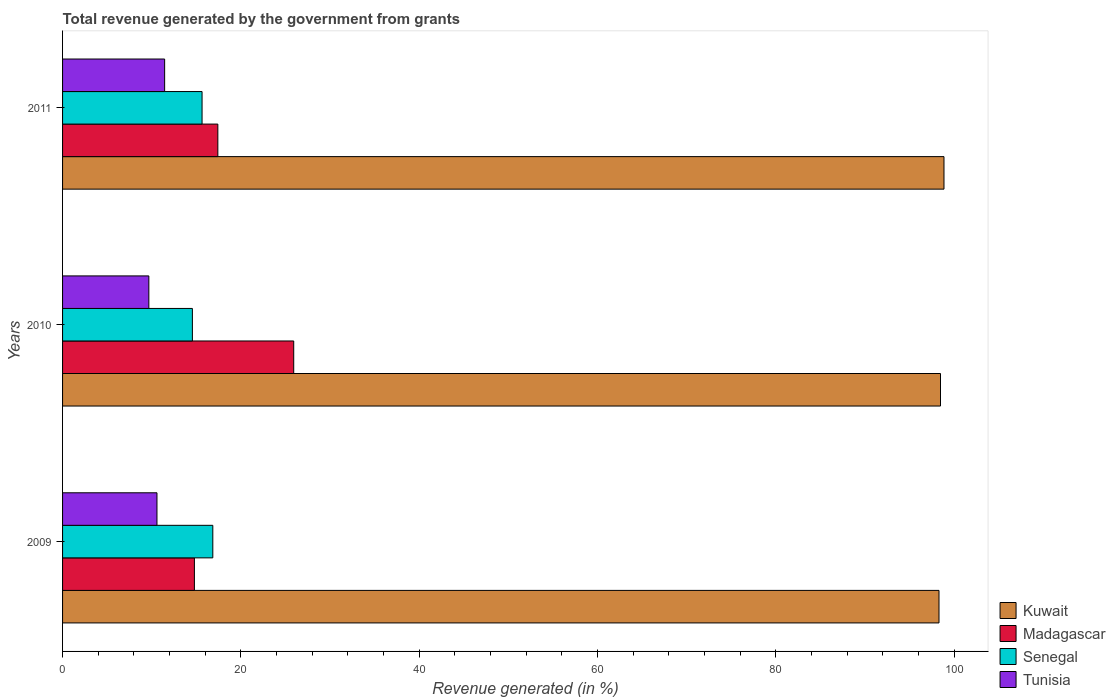Are the number of bars per tick equal to the number of legend labels?
Make the answer very short. Yes. What is the label of the 2nd group of bars from the top?
Provide a short and direct response. 2010. What is the total revenue generated in Madagascar in 2009?
Make the answer very short. 14.79. Across all years, what is the maximum total revenue generated in Senegal?
Offer a terse response. 16.85. Across all years, what is the minimum total revenue generated in Senegal?
Provide a short and direct response. 14.56. In which year was the total revenue generated in Tunisia minimum?
Your answer should be compact. 2010. What is the total total revenue generated in Madagascar in the graph?
Provide a short and direct response. 58.13. What is the difference between the total revenue generated in Senegal in 2009 and that in 2010?
Your answer should be very brief. 2.29. What is the difference between the total revenue generated in Senegal in 2010 and the total revenue generated in Tunisia in 2011?
Offer a very short reply. 3.11. What is the average total revenue generated in Senegal per year?
Your answer should be very brief. 15.69. In the year 2009, what is the difference between the total revenue generated in Madagascar and total revenue generated in Senegal?
Keep it short and to the point. -2.07. What is the ratio of the total revenue generated in Tunisia in 2009 to that in 2011?
Keep it short and to the point. 0.92. Is the total revenue generated in Senegal in 2009 less than that in 2011?
Ensure brevity in your answer.  No. What is the difference between the highest and the second highest total revenue generated in Tunisia?
Offer a terse response. 0.86. What is the difference between the highest and the lowest total revenue generated in Kuwait?
Your response must be concise. 0.56. In how many years, is the total revenue generated in Tunisia greater than the average total revenue generated in Tunisia taken over all years?
Your answer should be compact. 2. Is the sum of the total revenue generated in Tunisia in 2009 and 2010 greater than the maximum total revenue generated in Madagascar across all years?
Your answer should be very brief. No. Is it the case that in every year, the sum of the total revenue generated in Tunisia and total revenue generated in Kuwait is greater than the sum of total revenue generated in Madagascar and total revenue generated in Senegal?
Give a very brief answer. Yes. What does the 4th bar from the top in 2009 represents?
Offer a very short reply. Kuwait. What does the 3rd bar from the bottom in 2009 represents?
Your response must be concise. Senegal. Is it the case that in every year, the sum of the total revenue generated in Tunisia and total revenue generated in Kuwait is greater than the total revenue generated in Senegal?
Offer a very short reply. Yes. How many bars are there?
Give a very brief answer. 12. Where does the legend appear in the graph?
Your response must be concise. Bottom right. How many legend labels are there?
Offer a very short reply. 4. How are the legend labels stacked?
Your answer should be compact. Vertical. What is the title of the graph?
Your answer should be very brief. Total revenue generated by the government from grants. Does "Albania" appear as one of the legend labels in the graph?
Provide a succinct answer. No. What is the label or title of the X-axis?
Provide a short and direct response. Revenue generated (in %). What is the label or title of the Y-axis?
Provide a succinct answer. Years. What is the Revenue generated (in %) of Kuwait in 2009?
Offer a terse response. 98.31. What is the Revenue generated (in %) of Madagascar in 2009?
Provide a short and direct response. 14.79. What is the Revenue generated (in %) of Senegal in 2009?
Make the answer very short. 16.85. What is the Revenue generated (in %) of Tunisia in 2009?
Your response must be concise. 10.59. What is the Revenue generated (in %) of Kuwait in 2010?
Make the answer very short. 98.47. What is the Revenue generated (in %) in Madagascar in 2010?
Your response must be concise. 25.93. What is the Revenue generated (in %) in Senegal in 2010?
Ensure brevity in your answer.  14.56. What is the Revenue generated (in %) of Tunisia in 2010?
Keep it short and to the point. 9.68. What is the Revenue generated (in %) in Kuwait in 2011?
Provide a short and direct response. 98.86. What is the Revenue generated (in %) of Madagascar in 2011?
Give a very brief answer. 17.42. What is the Revenue generated (in %) in Senegal in 2011?
Ensure brevity in your answer.  15.65. What is the Revenue generated (in %) of Tunisia in 2011?
Your response must be concise. 11.45. Across all years, what is the maximum Revenue generated (in %) in Kuwait?
Your response must be concise. 98.86. Across all years, what is the maximum Revenue generated (in %) of Madagascar?
Offer a very short reply. 25.93. Across all years, what is the maximum Revenue generated (in %) in Senegal?
Make the answer very short. 16.85. Across all years, what is the maximum Revenue generated (in %) of Tunisia?
Your answer should be compact. 11.45. Across all years, what is the minimum Revenue generated (in %) of Kuwait?
Offer a terse response. 98.31. Across all years, what is the minimum Revenue generated (in %) in Madagascar?
Your response must be concise. 14.79. Across all years, what is the minimum Revenue generated (in %) of Senegal?
Offer a very short reply. 14.56. Across all years, what is the minimum Revenue generated (in %) of Tunisia?
Your answer should be compact. 9.68. What is the total Revenue generated (in %) of Kuwait in the graph?
Give a very brief answer. 295.64. What is the total Revenue generated (in %) in Madagascar in the graph?
Provide a short and direct response. 58.13. What is the total Revenue generated (in %) in Senegal in the graph?
Ensure brevity in your answer.  47.06. What is the total Revenue generated (in %) of Tunisia in the graph?
Provide a short and direct response. 31.71. What is the difference between the Revenue generated (in %) of Kuwait in 2009 and that in 2010?
Your answer should be compact. -0.17. What is the difference between the Revenue generated (in %) in Madagascar in 2009 and that in 2010?
Provide a short and direct response. -11.14. What is the difference between the Revenue generated (in %) in Senegal in 2009 and that in 2010?
Your answer should be compact. 2.29. What is the difference between the Revenue generated (in %) of Tunisia in 2009 and that in 2010?
Provide a succinct answer. 0.91. What is the difference between the Revenue generated (in %) in Kuwait in 2009 and that in 2011?
Make the answer very short. -0.56. What is the difference between the Revenue generated (in %) in Madagascar in 2009 and that in 2011?
Provide a short and direct response. -2.63. What is the difference between the Revenue generated (in %) of Senegal in 2009 and that in 2011?
Offer a very short reply. 1.21. What is the difference between the Revenue generated (in %) in Tunisia in 2009 and that in 2011?
Offer a terse response. -0.86. What is the difference between the Revenue generated (in %) of Kuwait in 2010 and that in 2011?
Your answer should be very brief. -0.39. What is the difference between the Revenue generated (in %) in Madagascar in 2010 and that in 2011?
Your response must be concise. 8.51. What is the difference between the Revenue generated (in %) of Senegal in 2010 and that in 2011?
Provide a succinct answer. -1.08. What is the difference between the Revenue generated (in %) in Tunisia in 2010 and that in 2011?
Make the answer very short. -1.77. What is the difference between the Revenue generated (in %) in Kuwait in 2009 and the Revenue generated (in %) in Madagascar in 2010?
Provide a succinct answer. 72.38. What is the difference between the Revenue generated (in %) in Kuwait in 2009 and the Revenue generated (in %) in Senegal in 2010?
Keep it short and to the point. 83.74. What is the difference between the Revenue generated (in %) of Kuwait in 2009 and the Revenue generated (in %) of Tunisia in 2010?
Ensure brevity in your answer.  88.63. What is the difference between the Revenue generated (in %) in Madagascar in 2009 and the Revenue generated (in %) in Senegal in 2010?
Make the answer very short. 0.23. What is the difference between the Revenue generated (in %) in Madagascar in 2009 and the Revenue generated (in %) in Tunisia in 2010?
Give a very brief answer. 5.11. What is the difference between the Revenue generated (in %) in Senegal in 2009 and the Revenue generated (in %) in Tunisia in 2010?
Provide a short and direct response. 7.18. What is the difference between the Revenue generated (in %) of Kuwait in 2009 and the Revenue generated (in %) of Madagascar in 2011?
Your response must be concise. 80.89. What is the difference between the Revenue generated (in %) of Kuwait in 2009 and the Revenue generated (in %) of Senegal in 2011?
Offer a very short reply. 82.66. What is the difference between the Revenue generated (in %) in Kuwait in 2009 and the Revenue generated (in %) in Tunisia in 2011?
Provide a succinct answer. 86.86. What is the difference between the Revenue generated (in %) in Madagascar in 2009 and the Revenue generated (in %) in Senegal in 2011?
Your response must be concise. -0.86. What is the difference between the Revenue generated (in %) in Madagascar in 2009 and the Revenue generated (in %) in Tunisia in 2011?
Keep it short and to the point. 3.34. What is the difference between the Revenue generated (in %) of Senegal in 2009 and the Revenue generated (in %) of Tunisia in 2011?
Ensure brevity in your answer.  5.4. What is the difference between the Revenue generated (in %) in Kuwait in 2010 and the Revenue generated (in %) in Madagascar in 2011?
Your response must be concise. 81.06. What is the difference between the Revenue generated (in %) of Kuwait in 2010 and the Revenue generated (in %) of Senegal in 2011?
Give a very brief answer. 82.83. What is the difference between the Revenue generated (in %) in Kuwait in 2010 and the Revenue generated (in %) in Tunisia in 2011?
Your response must be concise. 87.03. What is the difference between the Revenue generated (in %) in Madagascar in 2010 and the Revenue generated (in %) in Senegal in 2011?
Provide a short and direct response. 10.28. What is the difference between the Revenue generated (in %) of Madagascar in 2010 and the Revenue generated (in %) of Tunisia in 2011?
Your answer should be compact. 14.48. What is the difference between the Revenue generated (in %) in Senegal in 2010 and the Revenue generated (in %) in Tunisia in 2011?
Keep it short and to the point. 3.11. What is the average Revenue generated (in %) of Kuwait per year?
Make the answer very short. 98.55. What is the average Revenue generated (in %) in Madagascar per year?
Your answer should be compact. 19.38. What is the average Revenue generated (in %) in Senegal per year?
Provide a succinct answer. 15.69. What is the average Revenue generated (in %) in Tunisia per year?
Your answer should be very brief. 10.57. In the year 2009, what is the difference between the Revenue generated (in %) in Kuwait and Revenue generated (in %) in Madagascar?
Keep it short and to the point. 83.52. In the year 2009, what is the difference between the Revenue generated (in %) in Kuwait and Revenue generated (in %) in Senegal?
Offer a terse response. 81.45. In the year 2009, what is the difference between the Revenue generated (in %) in Kuwait and Revenue generated (in %) in Tunisia?
Provide a succinct answer. 87.72. In the year 2009, what is the difference between the Revenue generated (in %) in Madagascar and Revenue generated (in %) in Senegal?
Provide a succinct answer. -2.07. In the year 2009, what is the difference between the Revenue generated (in %) of Madagascar and Revenue generated (in %) of Tunisia?
Offer a terse response. 4.2. In the year 2009, what is the difference between the Revenue generated (in %) in Senegal and Revenue generated (in %) in Tunisia?
Provide a short and direct response. 6.26. In the year 2010, what is the difference between the Revenue generated (in %) in Kuwait and Revenue generated (in %) in Madagascar?
Provide a succinct answer. 72.55. In the year 2010, what is the difference between the Revenue generated (in %) in Kuwait and Revenue generated (in %) in Senegal?
Give a very brief answer. 83.91. In the year 2010, what is the difference between the Revenue generated (in %) in Kuwait and Revenue generated (in %) in Tunisia?
Keep it short and to the point. 88.8. In the year 2010, what is the difference between the Revenue generated (in %) in Madagascar and Revenue generated (in %) in Senegal?
Give a very brief answer. 11.37. In the year 2010, what is the difference between the Revenue generated (in %) of Madagascar and Revenue generated (in %) of Tunisia?
Offer a terse response. 16.25. In the year 2010, what is the difference between the Revenue generated (in %) of Senegal and Revenue generated (in %) of Tunisia?
Offer a terse response. 4.88. In the year 2011, what is the difference between the Revenue generated (in %) of Kuwait and Revenue generated (in %) of Madagascar?
Your response must be concise. 81.45. In the year 2011, what is the difference between the Revenue generated (in %) of Kuwait and Revenue generated (in %) of Senegal?
Give a very brief answer. 83.22. In the year 2011, what is the difference between the Revenue generated (in %) of Kuwait and Revenue generated (in %) of Tunisia?
Ensure brevity in your answer.  87.42. In the year 2011, what is the difference between the Revenue generated (in %) of Madagascar and Revenue generated (in %) of Senegal?
Offer a very short reply. 1.77. In the year 2011, what is the difference between the Revenue generated (in %) in Madagascar and Revenue generated (in %) in Tunisia?
Your response must be concise. 5.97. In the year 2011, what is the difference between the Revenue generated (in %) in Senegal and Revenue generated (in %) in Tunisia?
Your response must be concise. 4.2. What is the ratio of the Revenue generated (in %) in Kuwait in 2009 to that in 2010?
Your answer should be very brief. 1. What is the ratio of the Revenue generated (in %) of Madagascar in 2009 to that in 2010?
Provide a short and direct response. 0.57. What is the ratio of the Revenue generated (in %) in Senegal in 2009 to that in 2010?
Make the answer very short. 1.16. What is the ratio of the Revenue generated (in %) of Tunisia in 2009 to that in 2010?
Provide a succinct answer. 1.09. What is the ratio of the Revenue generated (in %) in Kuwait in 2009 to that in 2011?
Your answer should be very brief. 0.99. What is the ratio of the Revenue generated (in %) of Madagascar in 2009 to that in 2011?
Keep it short and to the point. 0.85. What is the ratio of the Revenue generated (in %) in Senegal in 2009 to that in 2011?
Offer a very short reply. 1.08. What is the ratio of the Revenue generated (in %) of Tunisia in 2009 to that in 2011?
Provide a short and direct response. 0.92. What is the ratio of the Revenue generated (in %) in Kuwait in 2010 to that in 2011?
Keep it short and to the point. 1. What is the ratio of the Revenue generated (in %) in Madagascar in 2010 to that in 2011?
Offer a very short reply. 1.49. What is the ratio of the Revenue generated (in %) of Senegal in 2010 to that in 2011?
Ensure brevity in your answer.  0.93. What is the ratio of the Revenue generated (in %) in Tunisia in 2010 to that in 2011?
Provide a succinct answer. 0.85. What is the difference between the highest and the second highest Revenue generated (in %) in Kuwait?
Your answer should be very brief. 0.39. What is the difference between the highest and the second highest Revenue generated (in %) in Madagascar?
Make the answer very short. 8.51. What is the difference between the highest and the second highest Revenue generated (in %) in Senegal?
Give a very brief answer. 1.21. What is the difference between the highest and the second highest Revenue generated (in %) of Tunisia?
Offer a terse response. 0.86. What is the difference between the highest and the lowest Revenue generated (in %) of Kuwait?
Offer a terse response. 0.56. What is the difference between the highest and the lowest Revenue generated (in %) of Madagascar?
Offer a very short reply. 11.14. What is the difference between the highest and the lowest Revenue generated (in %) in Senegal?
Provide a short and direct response. 2.29. What is the difference between the highest and the lowest Revenue generated (in %) in Tunisia?
Ensure brevity in your answer.  1.77. 